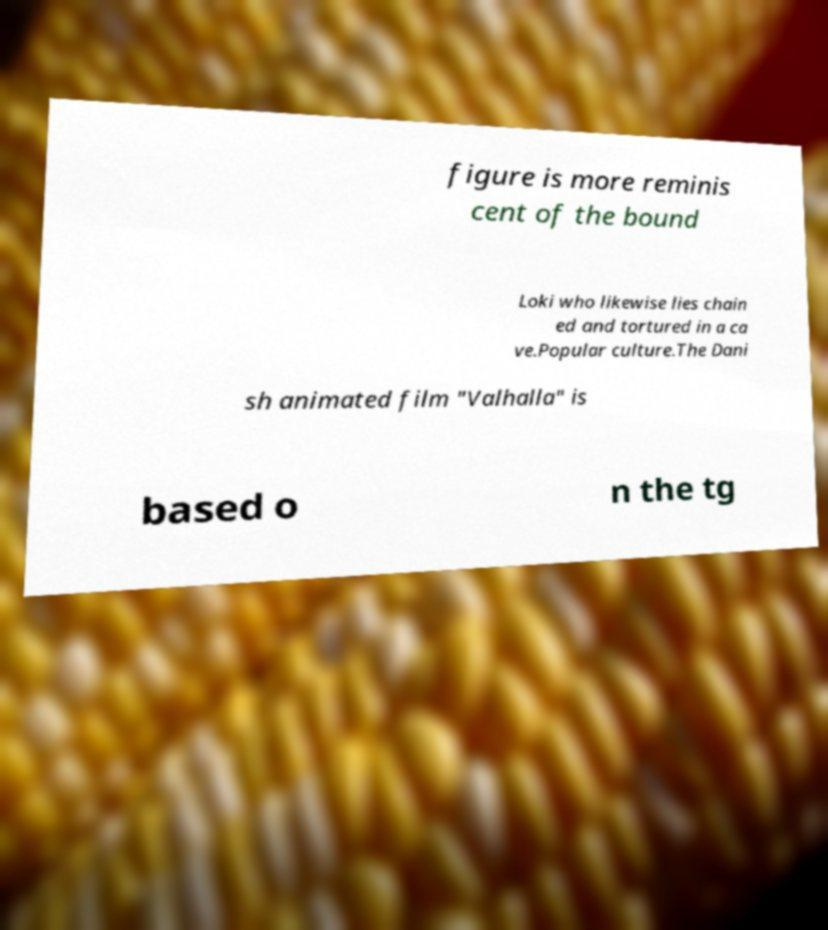Can you read and provide the text displayed in the image?This photo seems to have some interesting text. Can you extract and type it out for me? figure is more reminis cent of the bound Loki who likewise lies chain ed and tortured in a ca ve.Popular culture.The Dani sh animated film "Valhalla" is based o n the tg 